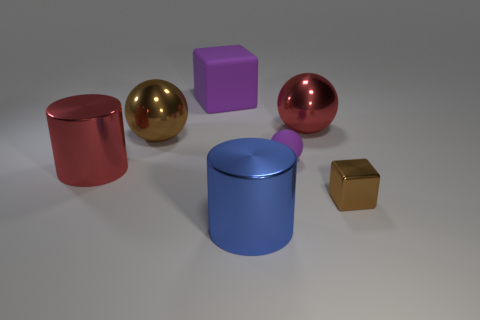Add 2 spheres. How many objects exist? 9 Subtract all cylinders. How many objects are left? 5 Subtract all tiny purple spheres. Subtract all big matte cubes. How many objects are left? 5 Add 2 tiny balls. How many tiny balls are left? 3 Add 7 red cubes. How many red cubes exist? 7 Subtract 0 brown cylinders. How many objects are left? 7 